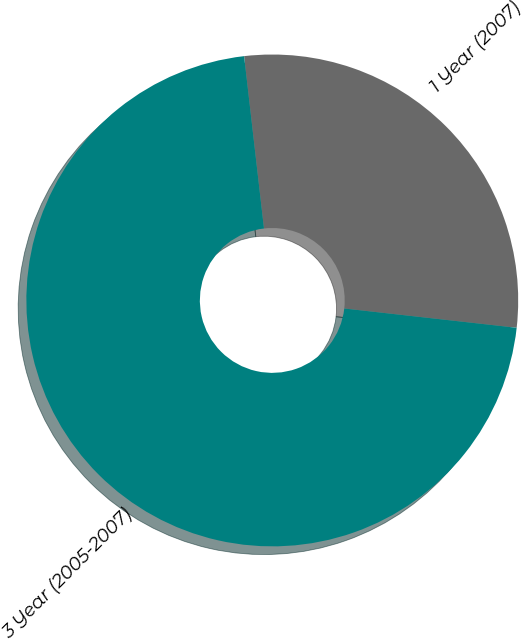<chart> <loc_0><loc_0><loc_500><loc_500><pie_chart><fcel>1 Year (2007)<fcel>3 Year (2005-2007)<nl><fcel>28.6%<fcel>71.4%<nl></chart> 